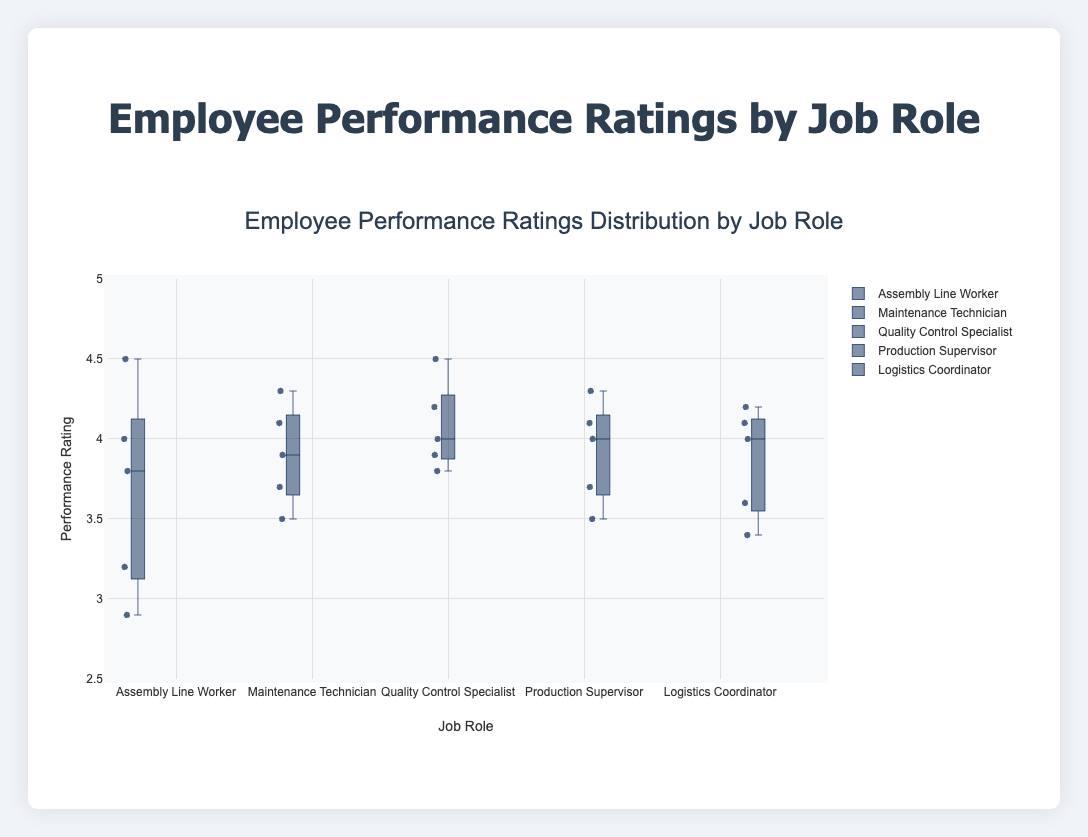What is the median performance rating for Quality Control Specialist? The median is found at the center of the sorted list of performance ratings for Quality Control Specialist. The ratings are: 3.8, 3.9, 4.0, 4.2, 4.5. The median value is the middle one, which is 4.0.
Answer: 4.0 Which job role has the highest median performance rating? To determine the highest median, compare the median values of each job role. The medians are: Assembly Line Worker (3.8), Maintenance Technician (3.9), Quality Control Specialist (4.0), Production Supervisor (4.0), Logistics Coordinator (4.0). The highest median value is 4.0, which is shared by Quality Control Specialist, Production Supervisor, and Logistics Coordinator.
Answer: Quality Control Specialist, Production Supervisor, Logistics Coordinator How many outliers are there for the Assembly Line Worker? Check the box plot for Assembly Line Worker to see any points plotted outside the "whiskers" of the plot, which represent outliers. There are no points plotted outside the whiskers for Assembly Line Worker.
Answer: 0 Which job role has the largest range in performance ratings? Calculate the range (maximum - minimum) for each job role: Assembly Line Worker (4.5 - 2.9 = 1.6), Maintenance Technician (4.3 - 3.5 = 0.8), Quality Control Specialist (4.5 - 3.8 = 0.7), Production Supervisor (4.3 - 3.5 = 0.8), Logistics Coordinator (4.2 - 3.4 = 0.8). The largest range is for Assembly Line Worker.
Answer: Assembly Line Worker What is the interquartile range (IQR) for Maintenance Technician? The IQR is the difference between the third quartile (Q3) and the first quartile (Q1). For Maintenance Technician, the performance ratings are: 3.5, 3.7, 3.9, 4.1, 4.3. Q1 (25th percentile) is 3.7, and Q3 (75th percentile) is 4.1. IQR is Q3 - Q1, so 4.1 - 3.7 = 0.4.
Answer: 0.4 Which job role has the smallest minimum performance rating? Compare the minimum performance ratings of each job role. Assembly Line Worker has the smallest minimum performance rating of 2.9.
Answer: Assembly Line Worker How do the medians of Production Supervisor and Logistics Coordinator compare? Compare the median values directly: Production Supervisor has a median of 4.0, and Logistics Coordinator also has a median of 4.0. They are equal.
Answer: Equal What is the maximum performance rating for the Assembly Line Worker? Refer to the highest point on the box plot for Assembly Line Worker. The maximum performance rating is 4.5.
Answer: 4.5 For which job role are the majority of ratings above 4.0? To judge the bulk of ratings visually, check the position of the median and interquartile range for each box plot against 4.0. The Performance Ratings for Quality Control Specialist show that at least the median and some part of the interquartile range is above 4.0.
Answer: Quality Control Specialist What is the performance rating range for the Production Supervisor? Calculate the range by subtracting the minimum value from the maximum one. For Production Supervisor, the maximum is 4.3 and the minimum is 3.5. The range is 4.3 - 3.5 = 0.8.
Answer: 0.8 